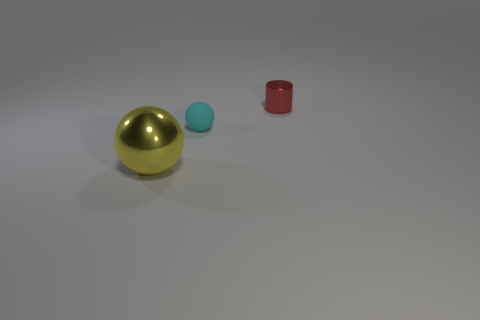Is there any other thing that has the same size as the yellow object?
Your answer should be compact. No. What size is the yellow shiny thing?
Your answer should be compact. Large. Is there a red shiny thing of the same shape as the small cyan matte object?
Offer a very short reply. No. There is a tiny red thing; is its shape the same as the metal object in front of the small metal cylinder?
Keep it short and to the point. No. What number of tiny matte cylinders are there?
Give a very brief answer. 0. What material is the thing that is the same size as the red shiny cylinder?
Your answer should be compact. Rubber. Are there any cyan matte objects of the same size as the shiny cylinder?
Ensure brevity in your answer.  Yes. What number of shiny objects are big green spheres or tiny red objects?
Make the answer very short. 1. There is a thing to the left of the ball behind the big yellow shiny thing; what number of small shiny cylinders are right of it?
Your answer should be very brief. 1. What size is the cylinder that is made of the same material as the big yellow object?
Keep it short and to the point. Small. 